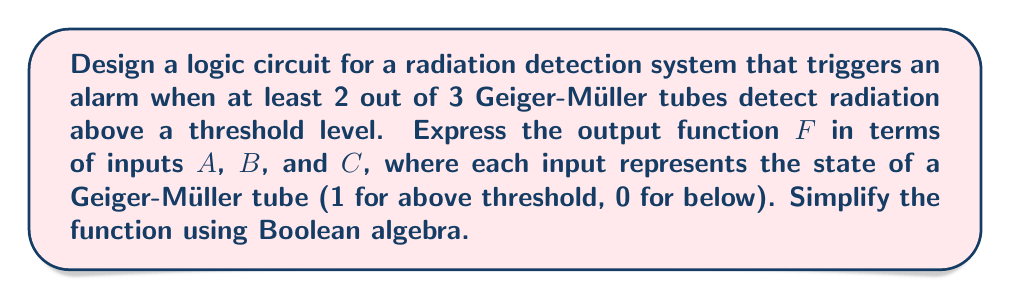What is the answer to this math problem? Let's approach this step-by-step:

1) First, we need to identify when the alarm should trigger. It should activate when at least 2 out of 3 inputs are 1. This can be represented as:

   $F = AB + AC + BC$

2) This expression can be expanded using the distributive law:

   $F = AB + AC + BC$
      $= AB(1 + C) + BC$
      $= AB + ABC + BC$

3) Now, we can apply the absorption law $(X + XY = X)$:

   $F = AB + BC + AC$

4) This is already in its simplest form, known as the "sum of products" or disjunctive normal form.

5) We can verify this result by checking all possible input combinations:

   - When 2 or 3 inputs are 1, at least one term will be 1, making $F = 1$
   - When 0 or 1 input is 1, all terms will be 0, making $F = 0$

This function can be implemented using AND gates for each product term and an OR gate to combine them.
Answer: $F = AB + BC + AC$ 